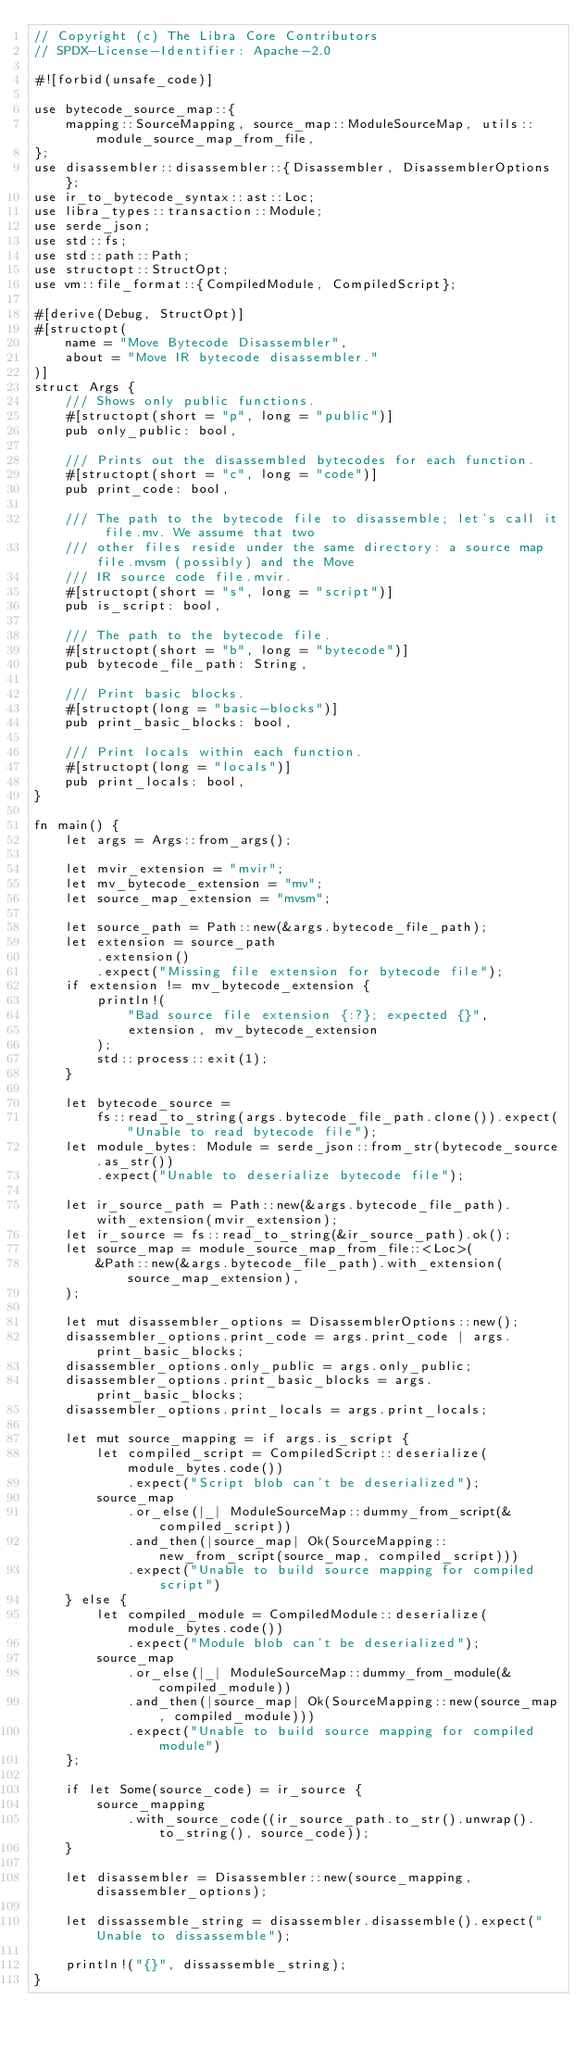<code> <loc_0><loc_0><loc_500><loc_500><_Rust_>// Copyright (c) The Libra Core Contributors
// SPDX-License-Identifier: Apache-2.0

#![forbid(unsafe_code)]

use bytecode_source_map::{
    mapping::SourceMapping, source_map::ModuleSourceMap, utils::module_source_map_from_file,
};
use disassembler::disassembler::{Disassembler, DisassemblerOptions};
use ir_to_bytecode_syntax::ast::Loc;
use libra_types::transaction::Module;
use serde_json;
use std::fs;
use std::path::Path;
use structopt::StructOpt;
use vm::file_format::{CompiledModule, CompiledScript};

#[derive(Debug, StructOpt)]
#[structopt(
    name = "Move Bytecode Disassembler",
    about = "Move IR bytecode disassembler."
)]
struct Args {
    /// Shows only public functions.
    #[structopt(short = "p", long = "public")]
    pub only_public: bool,

    /// Prints out the disassembled bytecodes for each function.
    #[structopt(short = "c", long = "code")]
    pub print_code: bool,

    /// The path to the bytecode file to disassemble; let's call it file.mv. We assume that two
    /// other files reside under the same directory: a source map file.mvsm (possibly) and the Move
    /// IR source code file.mvir.
    #[structopt(short = "s", long = "script")]
    pub is_script: bool,

    /// The path to the bytecode file.
    #[structopt(short = "b", long = "bytecode")]
    pub bytecode_file_path: String,

    /// Print basic blocks.
    #[structopt(long = "basic-blocks")]
    pub print_basic_blocks: bool,

    /// Print locals within each function.
    #[structopt(long = "locals")]
    pub print_locals: bool,
}

fn main() {
    let args = Args::from_args();

    let mvir_extension = "mvir";
    let mv_bytecode_extension = "mv";
    let source_map_extension = "mvsm";

    let source_path = Path::new(&args.bytecode_file_path);
    let extension = source_path
        .extension()
        .expect("Missing file extension for bytecode file");
    if extension != mv_bytecode_extension {
        println!(
            "Bad source file extension {:?}; expected {}",
            extension, mv_bytecode_extension
        );
        std::process::exit(1);
    }

    let bytecode_source =
        fs::read_to_string(args.bytecode_file_path.clone()).expect("Unable to read bytecode file");
    let module_bytes: Module = serde_json::from_str(bytecode_source.as_str())
        .expect("Unable to deserialize bytecode file");

    let ir_source_path = Path::new(&args.bytecode_file_path).with_extension(mvir_extension);
    let ir_source = fs::read_to_string(&ir_source_path).ok();
    let source_map = module_source_map_from_file::<Loc>(
        &Path::new(&args.bytecode_file_path).with_extension(source_map_extension),
    );

    let mut disassembler_options = DisassemblerOptions::new();
    disassembler_options.print_code = args.print_code | args.print_basic_blocks;
    disassembler_options.only_public = args.only_public;
    disassembler_options.print_basic_blocks = args.print_basic_blocks;
    disassembler_options.print_locals = args.print_locals;

    let mut source_mapping = if args.is_script {
        let compiled_script = CompiledScript::deserialize(module_bytes.code())
            .expect("Script blob can't be deserialized");
        source_map
            .or_else(|_| ModuleSourceMap::dummy_from_script(&compiled_script))
            .and_then(|source_map| Ok(SourceMapping::new_from_script(source_map, compiled_script)))
            .expect("Unable to build source mapping for compiled script")
    } else {
        let compiled_module = CompiledModule::deserialize(module_bytes.code())
            .expect("Module blob can't be deserialized");
        source_map
            .or_else(|_| ModuleSourceMap::dummy_from_module(&compiled_module))
            .and_then(|source_map| Ok(SourceMapping::new(source_map, compiled_module)))
            .expect("Unable to build source mapping for compiled module")
    };

    if let Some(source_code) = ir_source {
        source_mapping
            .with_source_code((ir_source_path.to_str().unwrap().to_string(), source_code));
    }

    let disassembler = Disassembler::new(source_mapping, disassembler_options);

    let dissassemble_string = disassembler.disassemble().expect("Unable to dissassemble");

    println!("{}", dissassemble_string);
}
</code> 